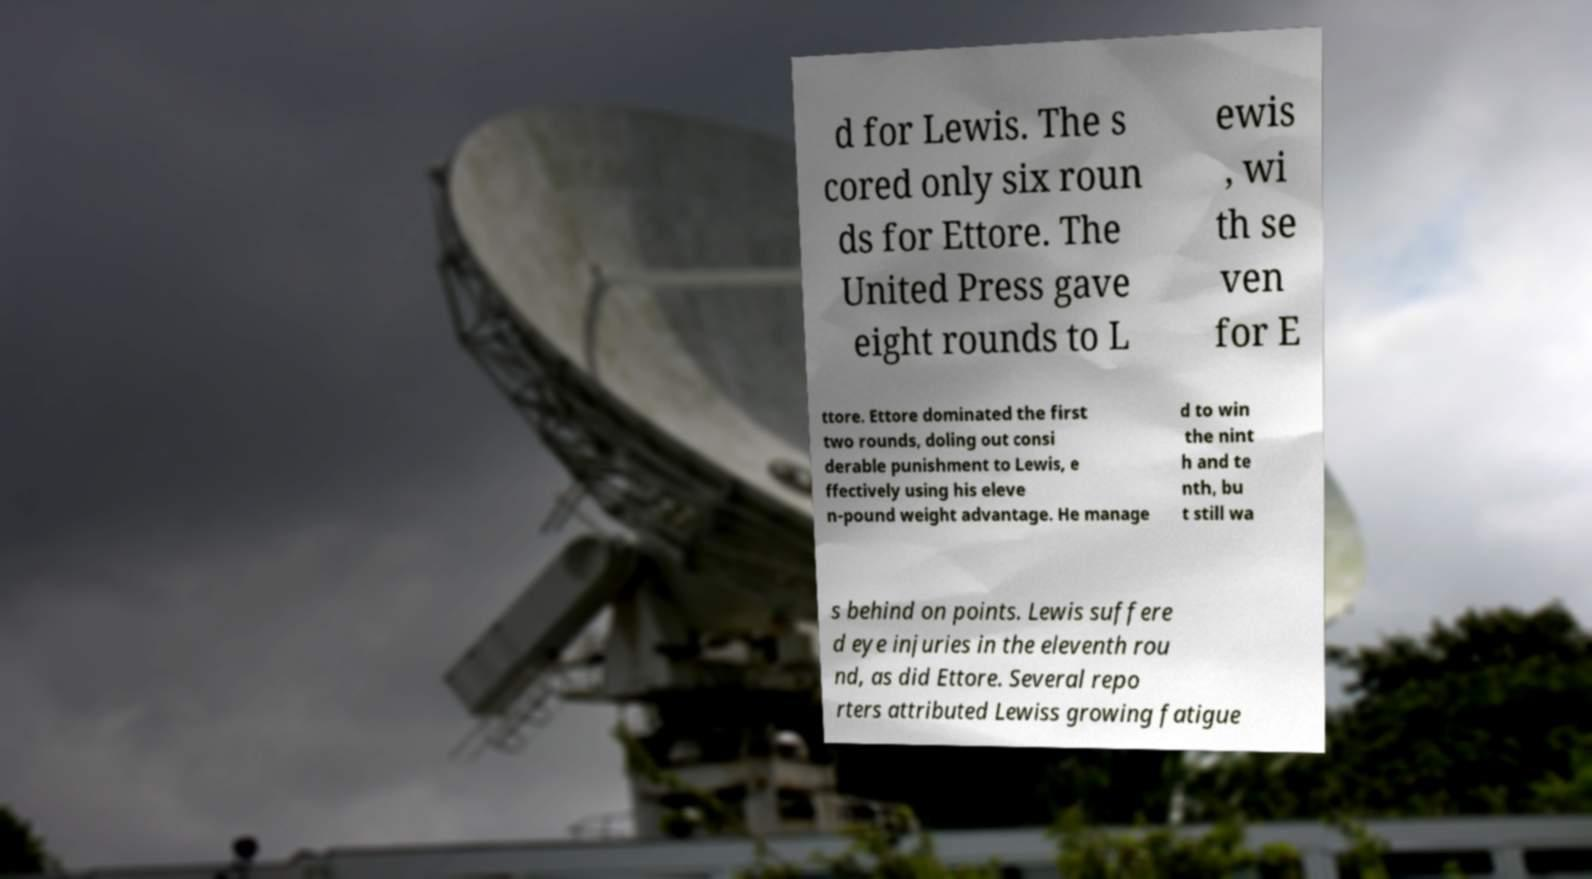For documentation purposes, I need the text within this image transcribed. Could you provide that? d for Lewis. The s cored only six roun ds for Ettore. The United Press gave eight rounds to L ewis , wi th se ven for E ttore. Ettore dominated the first two rounds, doling out consi derable punishment to Lewis, e ffectively using his eleve n-pound weight advantage. He manage d to win the nint h and te nth, bu t still wa s behind on points. Lewis suffere d eye injuries in the eleventh rou nd, as did Ettore. Several repo rters attributed Lewiss growing fatigue 